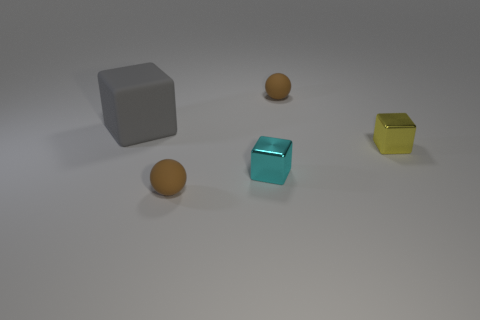What is the shape of the small object that is made of the same material as the yellow cube?
Your response must be concise. Cube. There is a rubber thing that is both to the right of the big gray block and behind the yellow shiny block; what is its color?
Make the answer very short. Brown. Do the brown thing behind the big gray rubber cube and the large gray cube have the same material?
Give a very brief answer. Yes. Are there fewer yellow shiny objects that are in front of the cyan shiny thing than large green matte objects?
Offer a very short reply. No. Is there a cyan object made of the same material as the cyan cube?
Provide a succinct answer. No. There is a yellow block; is it the same size as the sphere in front of the big thing?
Offer a terse response. Yes. Are there any metal cubes that have the same color as the rubber cube?
Keep it short and to the point. No. Are there the same number of tiny yellow blocks and brown spheres?
Give a very brief answer. No. Does the tiny yellow thing have the same material as the gray thing?
Keep it short and to the point. No. There is a tiny yellow metal cube; how many tiny cyan blocks are on the right side of it?
Your answer should be very brief. 0. 